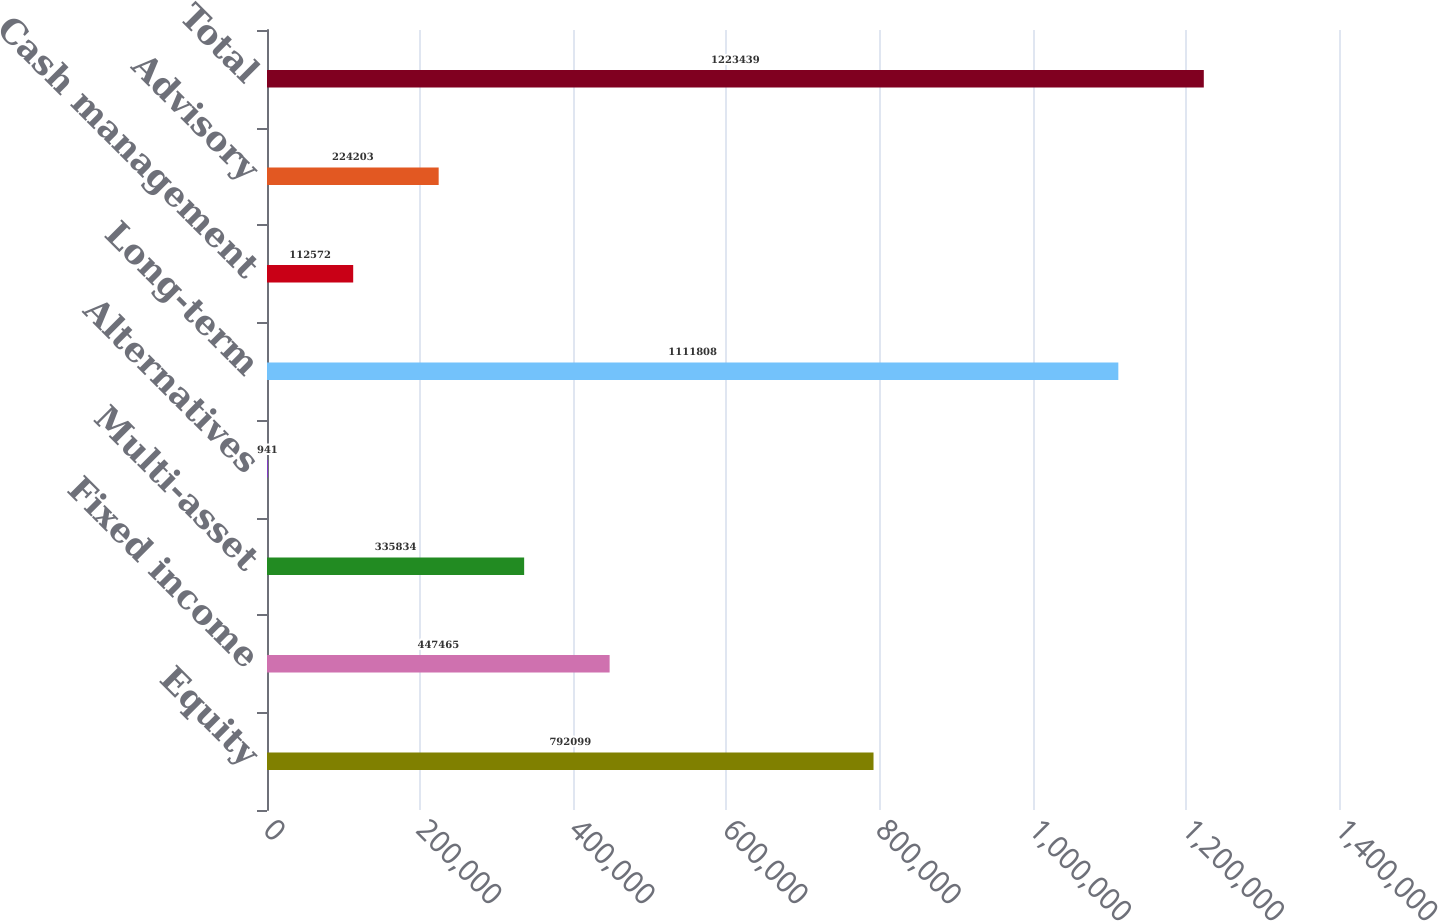<chart> <loc_0><loc_0><loc_500><loc_500><bar_chart><fcel>Equity<fcel>Fixed income<fcel>Multi-asset<fcel>Alternatives<fcel>Long-term<fcel>Cash management<fcel>Advisory<fcel>Total<nl><fcel>792099<fcel>447465<fcel>335834<fcel>941<fcel>1.11181e+06<fcel>112572<fcel>224203<fcel>1.22344e+06<nl></chart> 